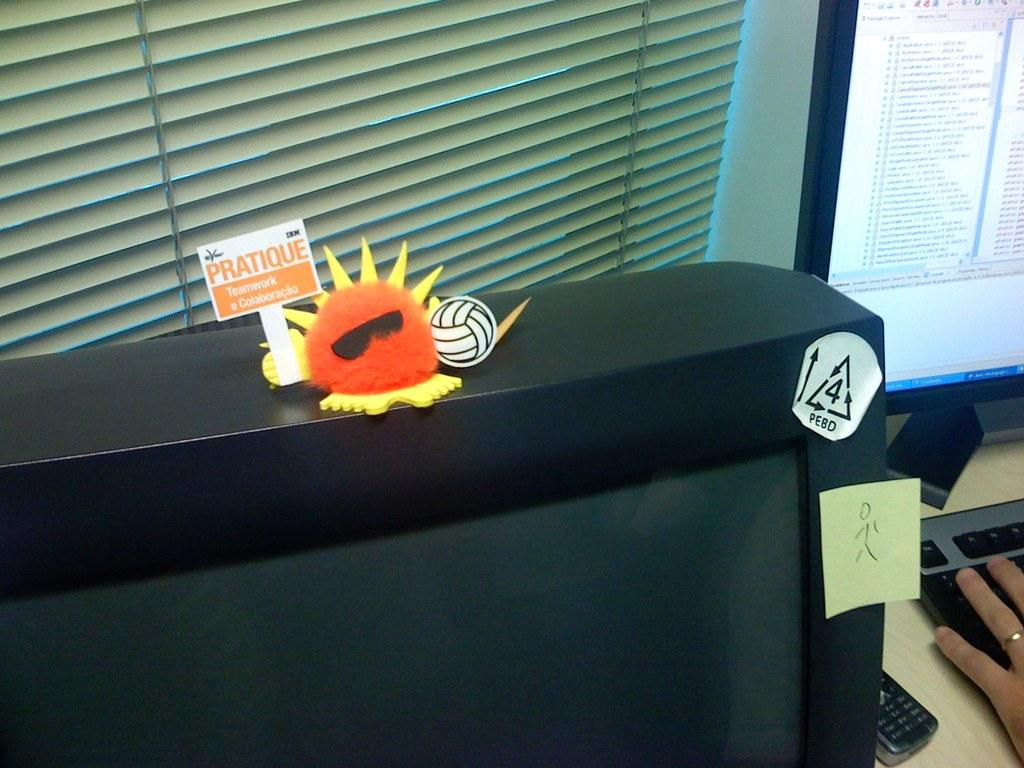What electronic device is present in the image? There is a computer in the image. What part of a person can be seen in the image? A human hand is visible in the image. What other electronic device is present in the image? There is a mobile in the image. How many monitors are visible in the image? There is another monitor in the image. What is placed on the monitor? There is placed on the monitor. What type of window treatment is present in the image? Blinds are present near a window in the image. How many sheep are visible in the image? There are no sheep present in the image. What type of poison is being used by the parent in the image? There is no parent or poison present in the image. 